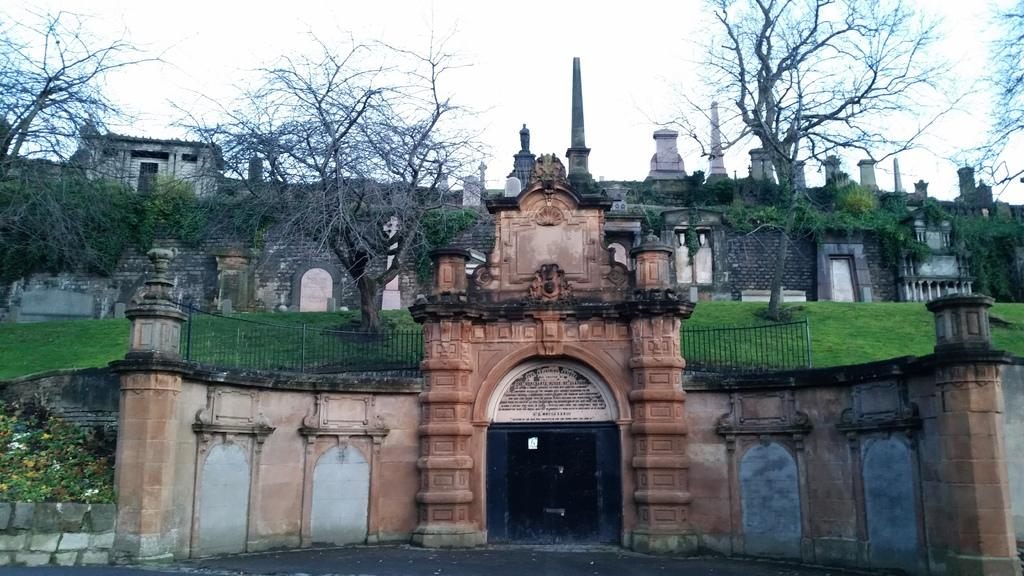What type of structures are present in the image? There are buildings in the image. What can be seen on both sides of the image? There is railing and trees on both sides of the image. What type of vegetation is present on the left side of the image? There are flowers and plants on the left side of the image. What is visible in the background of the image? The sky is visible in the background of the image. Can you see any snakes slithering on the railing in the image? There are no snakes present in the image; the railing is clear of any such creatures. Are there any sisters standing near the trees in the image? There is no mention of any people, let alone sisters, in the image. 